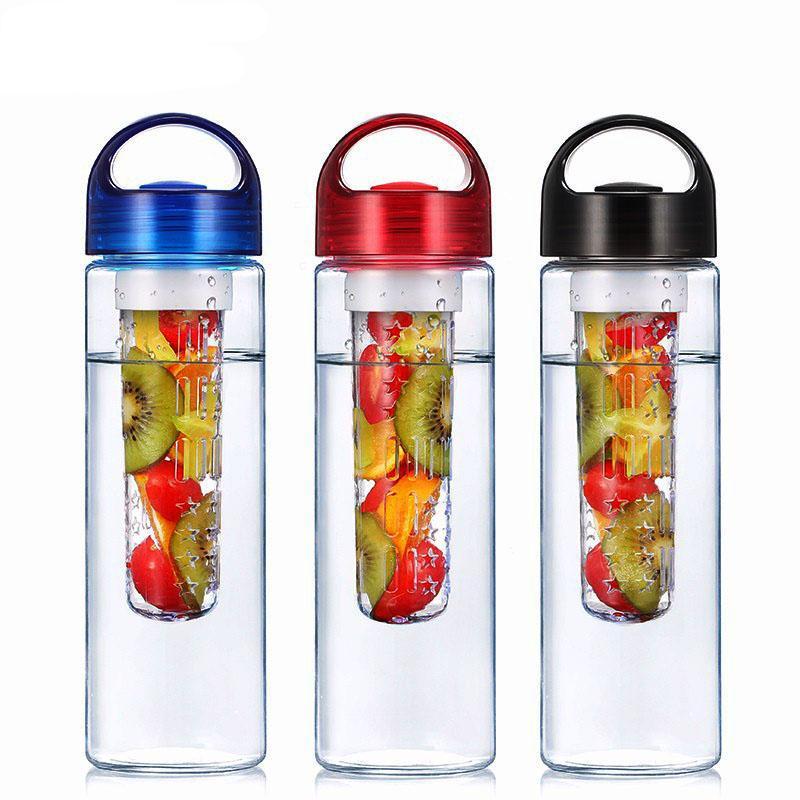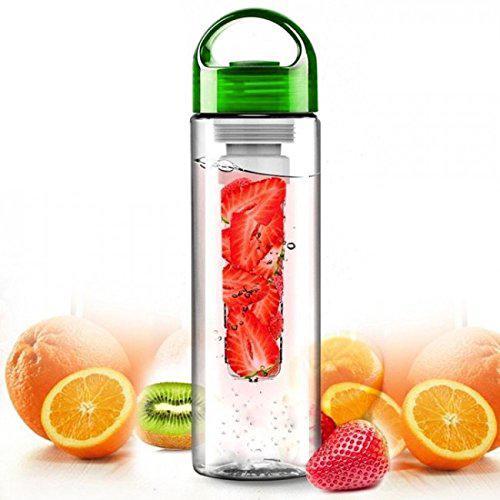The first image is the image on the left, the second image is the image on the right. Examine the images to the left and right. Is the description "There are fruits near the glasses in one of the images." accurate? Answer yes or no. Yes. 